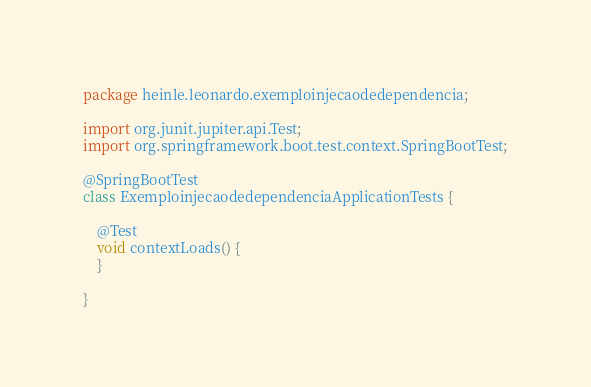Convert code to text. <code><loc_0><loc_0><loc_500><loc_500><_Java_>package heinle.leonardo.exemploinjecaodedependencia;

import org.junit.jupiter.api.Test;
import org.springframework.boot.test.context.SpringBootTest;

@SpringBootTest
class ExemploinjecaodedependenciaApplicationTests {

	@Test
	void contextLoads() {
	}

}
</code> 